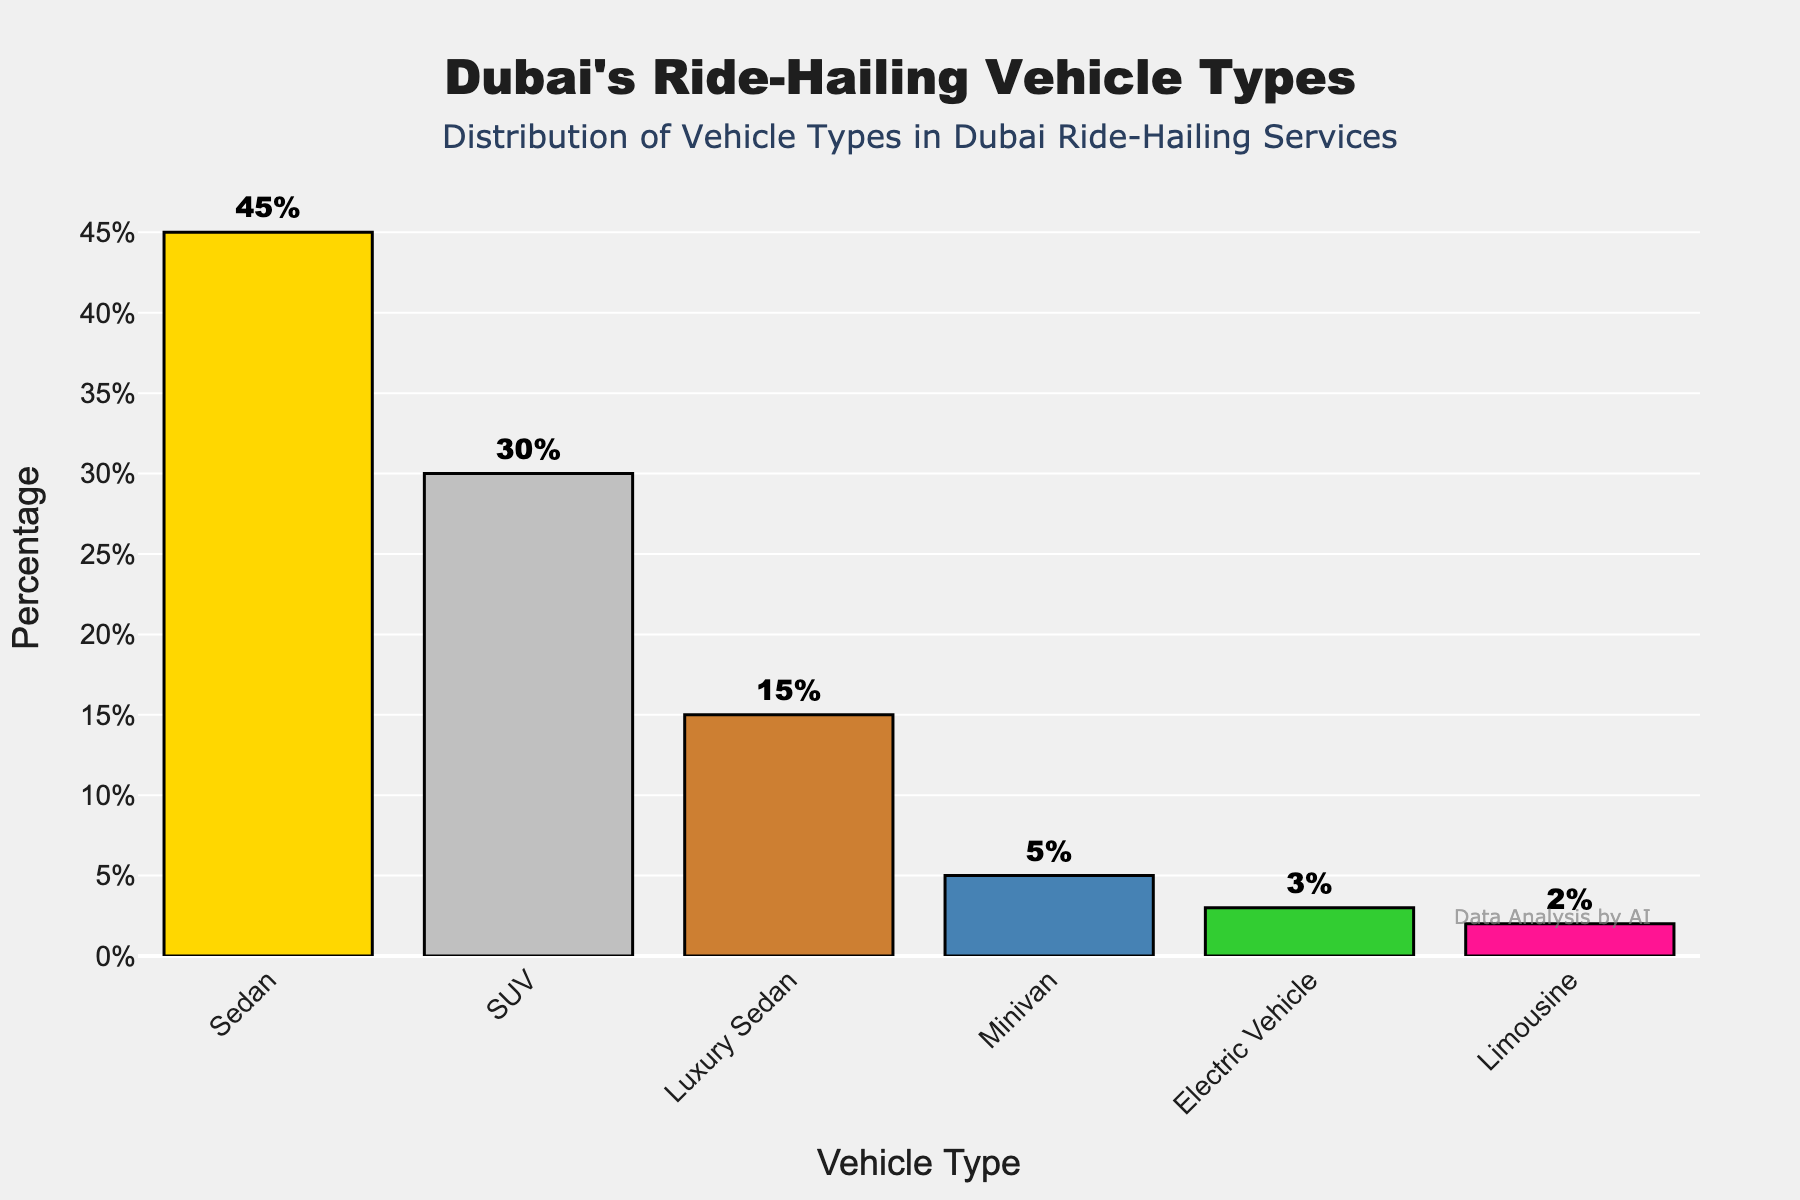Which vehicle type is the most common in Dubai's ride-hailing services? The bar representing "Sedan" is the tallest among the vehicle types, indicating it has the highest percentage at 45%.
Answer: Sedan Which vehicle type is the least common? The shortest bar represents the "Limousine" category, indicating it has the lowest percentage at 2%.
Answer: Limousine What is the difference in percentage between SUVs and Luxury Sedans? The bar for SUVs is at 30%, and Luxury Sedans is at 15%. The difference is 30% - 15% = 15%.
Answer: 15% What is the total percentage of Sedan and SUV vehicles? The bar for Sedans is at 45% and for SUVs is at 30%. The total is 45% + 30% = 75%.
Answer: 75% Which vehicle type has the second-highest percentage? The second tallest bar represents the "SUV" category, indicating it has the second-highest percentage at 30%.
Answer: SUV Are Luxury Sedans more common than Electric Vehicles? Yes, the bar for Luxury Sedans (15%) is taller than the bar for Electric Vehicles (3%).
Answer: Yes How much more common are Sedans compared to Minivans? The bar for Sedans is at 45% and the bar for Minivans is at 5%. The difference is 45% - 5% = 40%.
Answer: 40% What is the combined percentage of Electric Vehicles and Limousines? The bar for Electric Vehicles is at 3% and the bar for Limousines is at 2%. The combined percentage is 3% + 2% = 5%.
Answer: 5% How does the percentage of Luxury Sedans compare to Minivans and Electric Vehicles combined? The bar for Luxury Sedans is at 15%. Minivans are at 5% and Electric Vehicles are at 3%. The combined percentage for Minivans and Electric Vehicles is 5% + 3% = 8%, which is less than 15%.
Answer: It is higher Which vehicle type falls exactly in the middle of the percentage range? The vehicle types sorted by percentage are: Limousine (2%), Electric Vehicle (3%), Minivan (5%), Luxury Sedan (15%), SUV (30%), Sedan (45%). The middle vehicle type is Luxury Sedan at 15%.
Answer: Luxury Sedan 